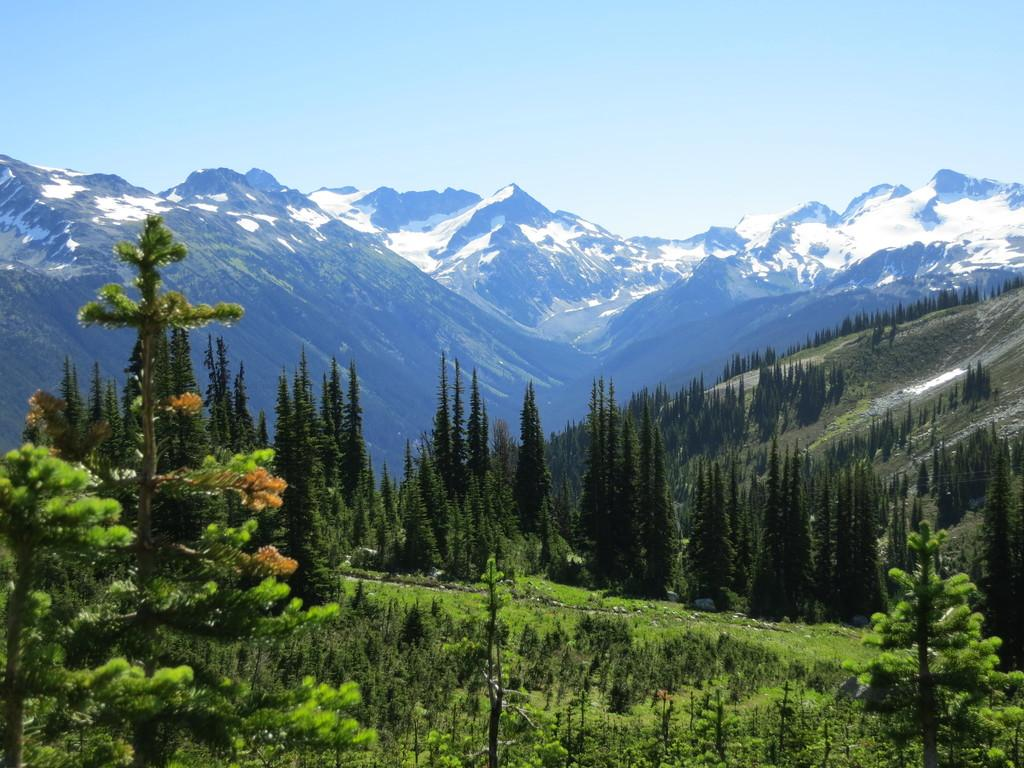Where was the picture taken? The picture was clicked outside the city. What can be seen in the foreground of the image? There are plants, green grass, and trees in the foreground. What type of landscape is visible in the image? Hills are visible in the image. What is visible in the background of the image? The sky is visible in the background. What type of cheese is being used as a badge in the image? There is no cheese or badge present in the image. What hobbies are the plants in the foreground engaged in? Plants do not have hobbies, as they are not living beings with the ability to engage in activities or interests. 